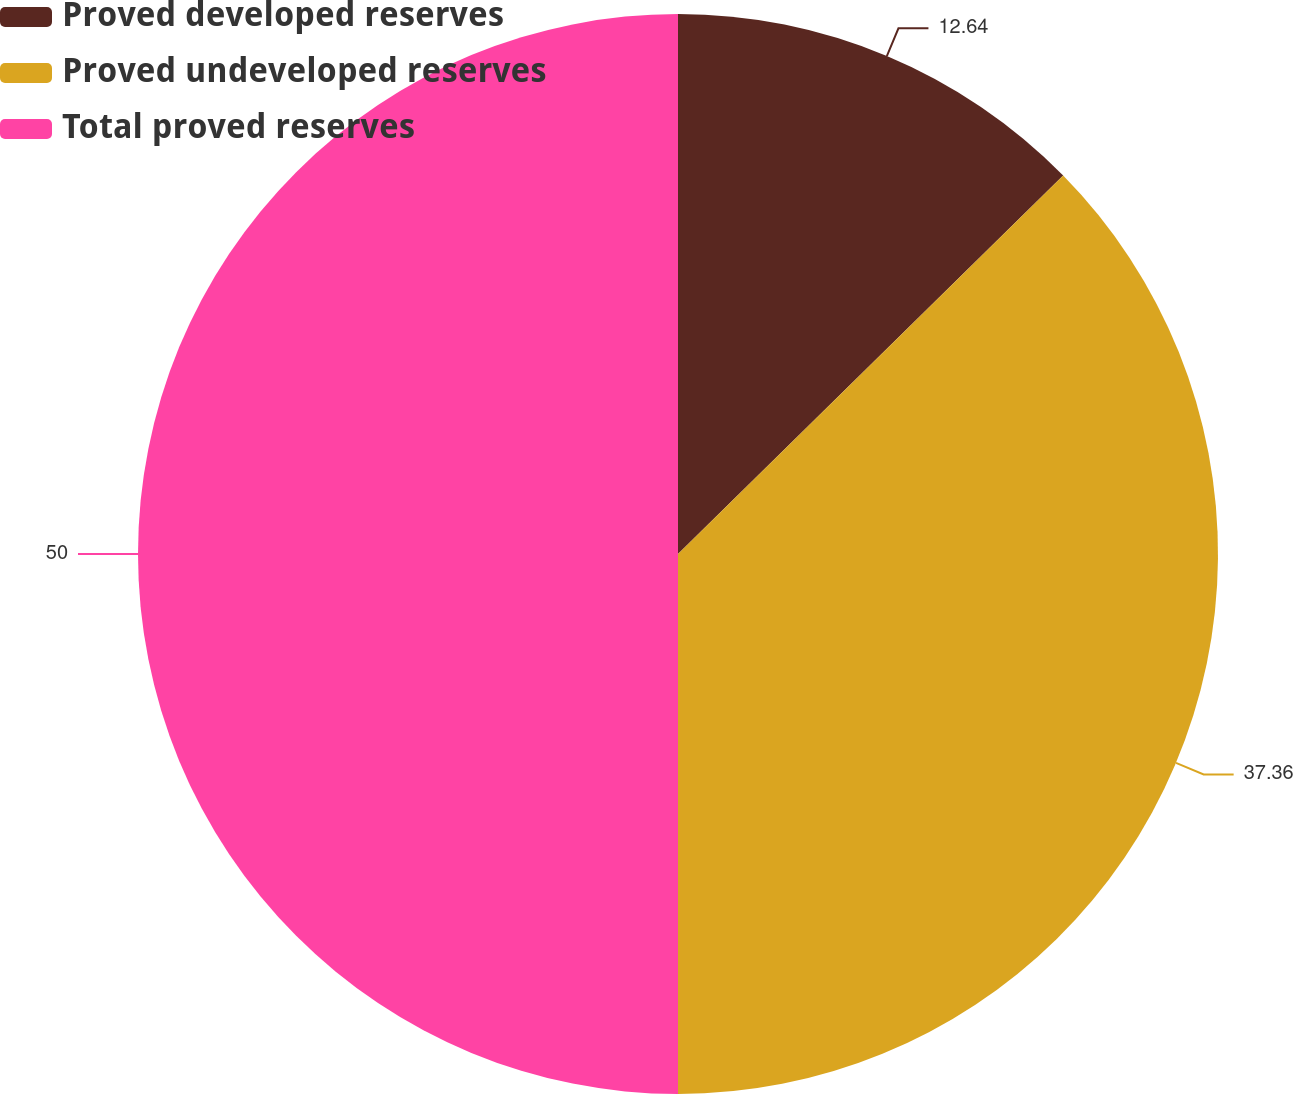Convert chart. <chart><loc_0><loc_0><loc_500><loc_500><pie_chart><fcel>Proved developed reserves<fcel>Proved undeveloped reserves<fcel>Total proved reserves<nl><fcel>12.64%<fcel>37.36%<fcel>50.0%<nl></chart> 